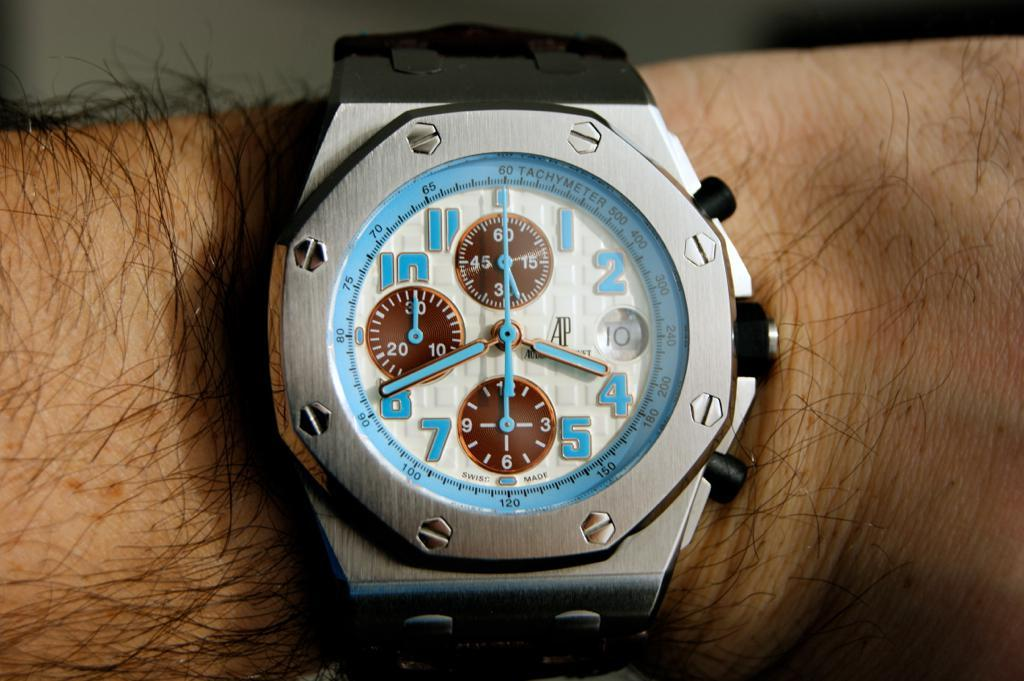<image>
Present a compact description of the photo's key features. Silver watch with blue dial shows 3:40 on the dial. 